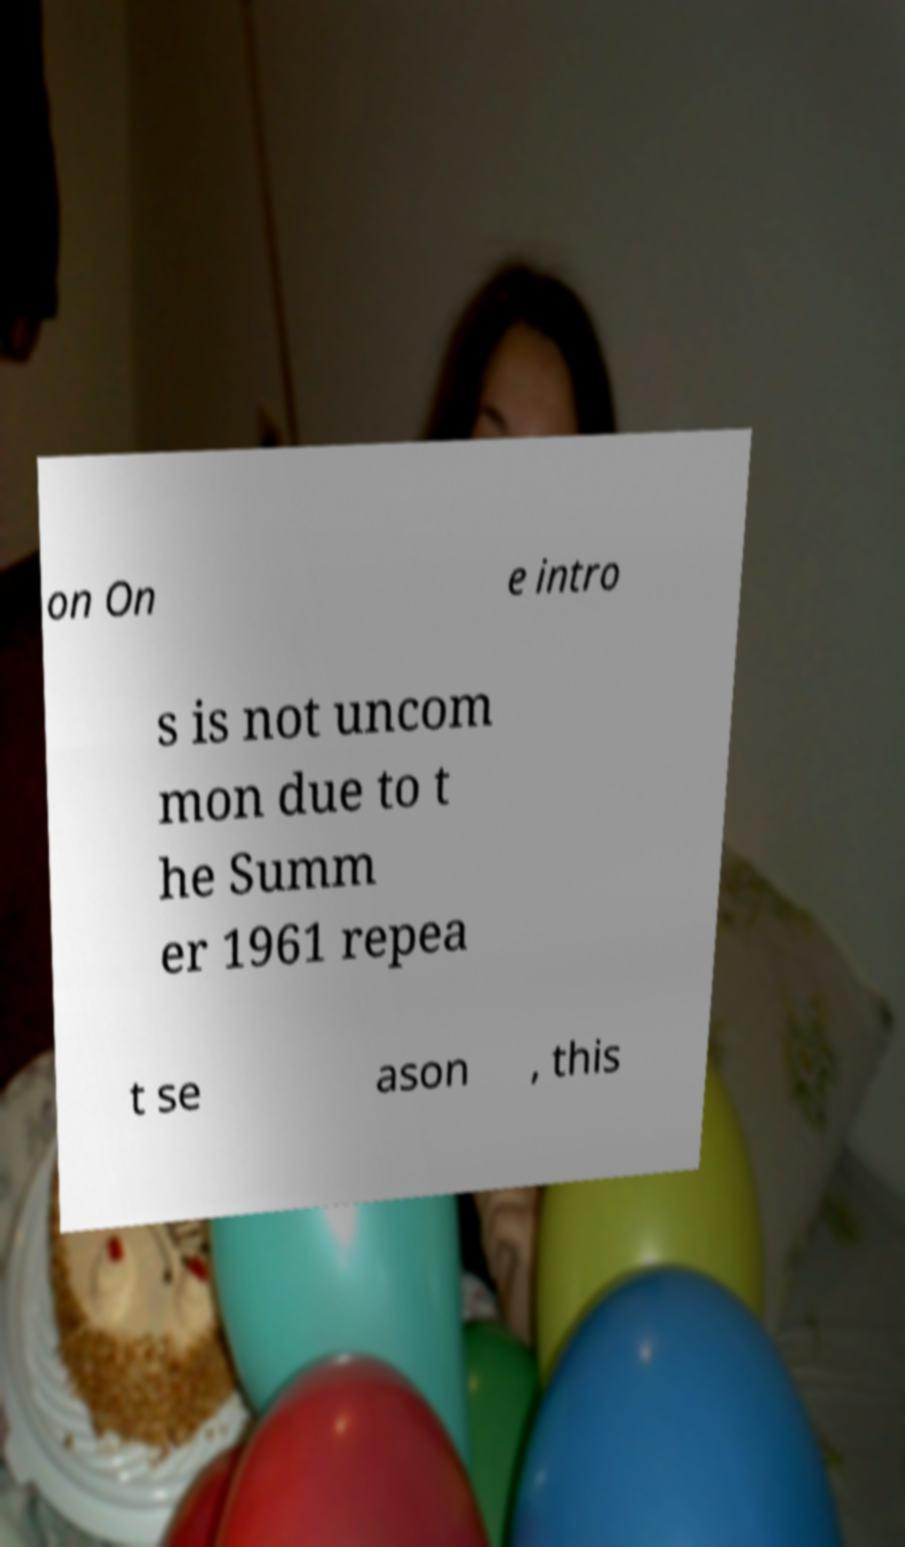Please identify and transcribe the text found in this image. on On e intro s is not uncom mon due to t he Summ er 1961 repea t se ason , this 